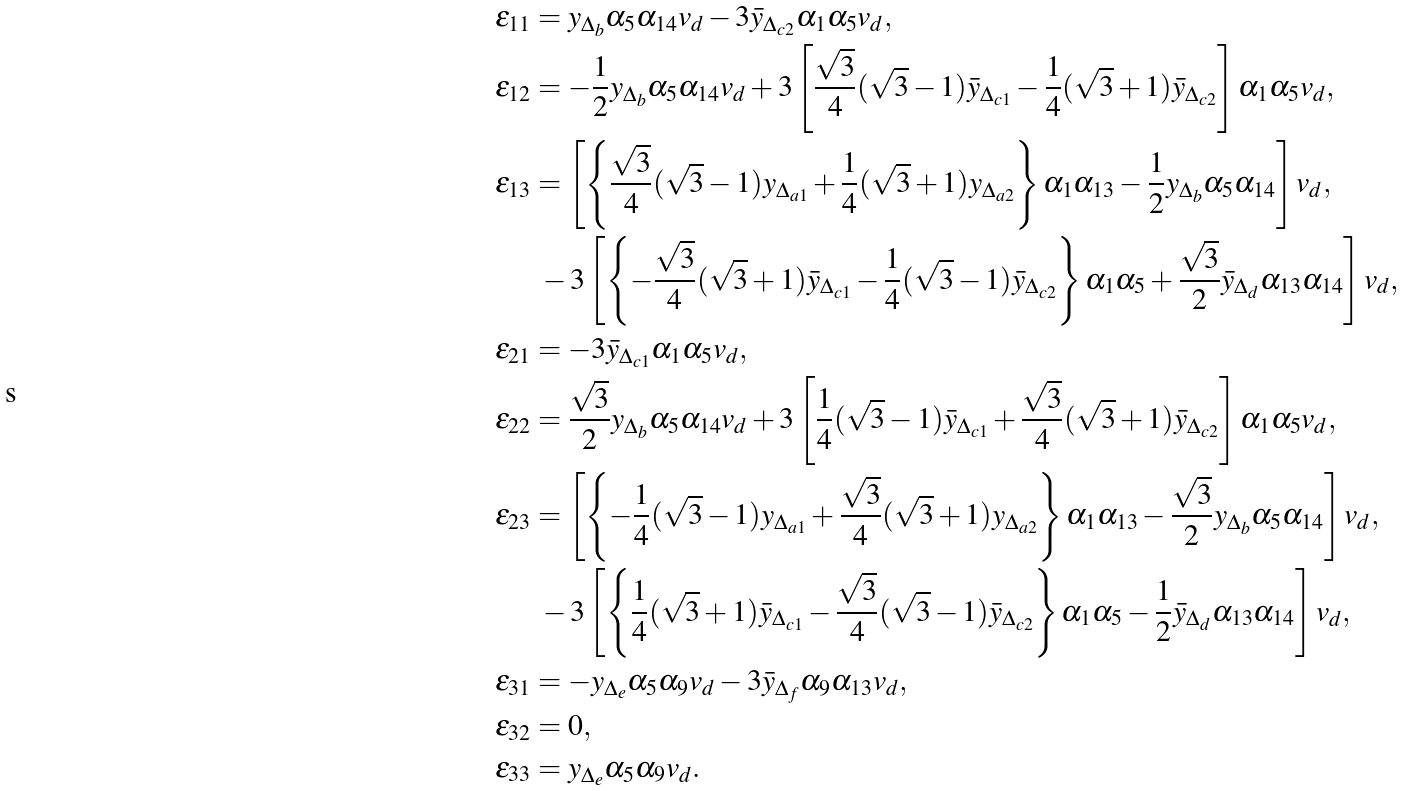Convert formula to latex. <formula><loc_0><loc_0><loc_500><loc_500>\epsilon _ { 1 1 } & = y _ { \Delta _ { b } } \alpha _ { 5 } \alpha _ { 1 4 } v _ { d } - 3 \bar { y } _ { \Delta _ { c 2 } } \alpha _ { 1 } \alpha _ { 5 } v _ { d } , \\ \epsilon _ { 1 2 } & = - \frac { 1 } { 2 } y _ { \Delta _ { b } } \alpha _ { 5 } \alpha _ { 1 4 } v _ { d } + 3 \left [ \frac { \sqrt { 3 } } { 4 } ( \sqrt { 3 } - 1 ) \bar { y } _ { \Delta _ { c 1 } } - \frac { 1 } { 4 } ( \sqrt { 3 } + 1 ) \bar { y } _ { \Delta _ { c 2 } } \right ] \alpha _ { 1 } \alpha _ { 5 } v _ { d } , \\ \epsilon _ { 1 3 } & = \left [ \left \{ \frac { \sqrt { 3 } } { 4 } ( \sqrt { 3 } - 1 ) y _ { \Delta _ { a 1 } } + \frac { 1 } { 4 } ( \sqrt { 3 } + 1 ) y _ { \Delta _ { a 2 } } \right \} \alpha _ { 1 } \alpha _ { 1 3 } - \frac { 1 } { 2 } y _ { \Delta _ { b } } \alpha _ { 5 } \alpha _ { 1 4 } \right ] v _ { d } , \\ & \ - 3 \left [ \left \{ - \frac { \sqrt { 3 } } { 4 } ( \sqrt { 3 } + 1 ) \bar { y } _ { \Delta _ { c 1 } } - \frac { 1 } { 4 } ( \sqrt { 3 } - 1 ) \bar { y } _ { \Delta _ { c 2 } } \right \} \alpha _ { 1 } \alpha _ { 5 } + \frac { \sqrt { 3 } } { 2 } \bar { y } _ { \Delta _ { d } } \alpha _ { 1 3 } \alpha _ { 1 4 } \right ] v _ { d } , \\ \epsilon _ { 2 1 } & = - 3 \bar { y } _ { \Delta _ { c 1 } } \alpha _ { 1 } \alpha _ { 5 } v _ { d } , \\ \epsilon _ { 2 2 } & = \frac { \sqrt { 3 } } { 2 } y _ { \Delta _ { b } } \alpha _ { 5 } \alpha _ { 1 4 } v _ { d } + 3 \left [ \frac { 1 } { 4 } ( \sqrt { 3 } - 1 ) \bar { y } _ { \Delta _ { c 1 } } + \frac { \sqrt { 3 } } { 4 } ( \sqrt { 3 } + 1 ) \bar { y } _ { \Delta _ { c 2 } } \right ] \alpha _ { 1 } \alpha _ { 5 } v _ { d } , \\ \epsilon _ { 2 3 } & = \left [ \left \{ - \frac { 1 } { 4 } ( \sqrt { 3 } - 1 ) y _ { \Delta _ { a 1 } } + \frac { \sqrt { 3 } } { 4 } ( \sqrt { 3 } + 1 ) y _ { \Delta _ { a 2 } } \right \} \alpha _ { 1 } \alpha _ { 1 3 } - \frac { \sqrt { 3 } } { 2 } y _ { \Delta _ { b } } \alpha _ { 5 } \alpha _ { 1 4 } \right ] v _ { d } , \\ & \ - 3 \left [ \left \{ \frac { 1 } { 4 } ( \sqrt { 3 } + 1 ) \bar { y } _ { \Delta _ { c 1 } } - \frac { \sqrt { 3 } } { 4 } ( \sqrt { 3 } - 1 ) \bar { y } _ { \Delta _ { c 2 } } \right \} \alpha _ { 1 } \alpha _ { 5 } - \frac { 1 } { 2 } \bar { y } _ { \Delta _ { d } } \alpha _ { 1 3 } \alpha _ { 1 4 } \right ] v _ { d } , \\ \epsilon _ { 3 1 } & = - y _ { \Delta _ { e } } \alpha _ { 5 } \alpha _ { 9 } v _ { d } - 3 \bar { y } _ { \Delta _ { f } } \alpha _ { 9 } \alpha _ { 1 3 } v _ { d } , \\ \epsilon _ { 3 2 } & = 0 , \\ \epsilon _ { 3 3 } & = y _ { \Delta _ { e } } \alpha _ { 5 } \alpha _ { 9 } v _ { d } .</formula> 